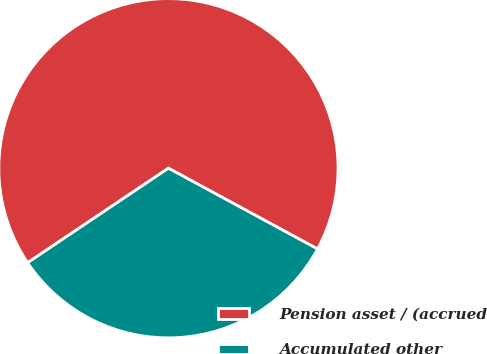Convert chart to OTSL. <chart><loc_0><loc_0><loc_500><loc_500><pie_chart><fcel>Pension asset / (accrued<fcel>Accumulated other<nl><fcel>67.31%<fcel>32.69%<nl></chart> 